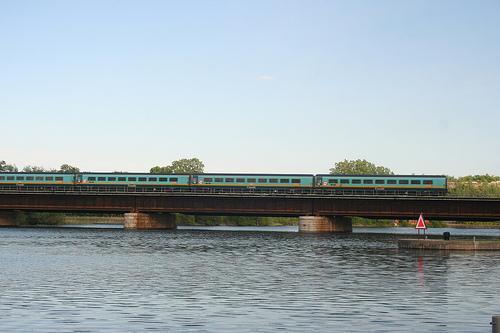How many train cars are visible?
Give a very brief answer. 4. How many bridge supports are visible?
Give a very brief answer. 2. 